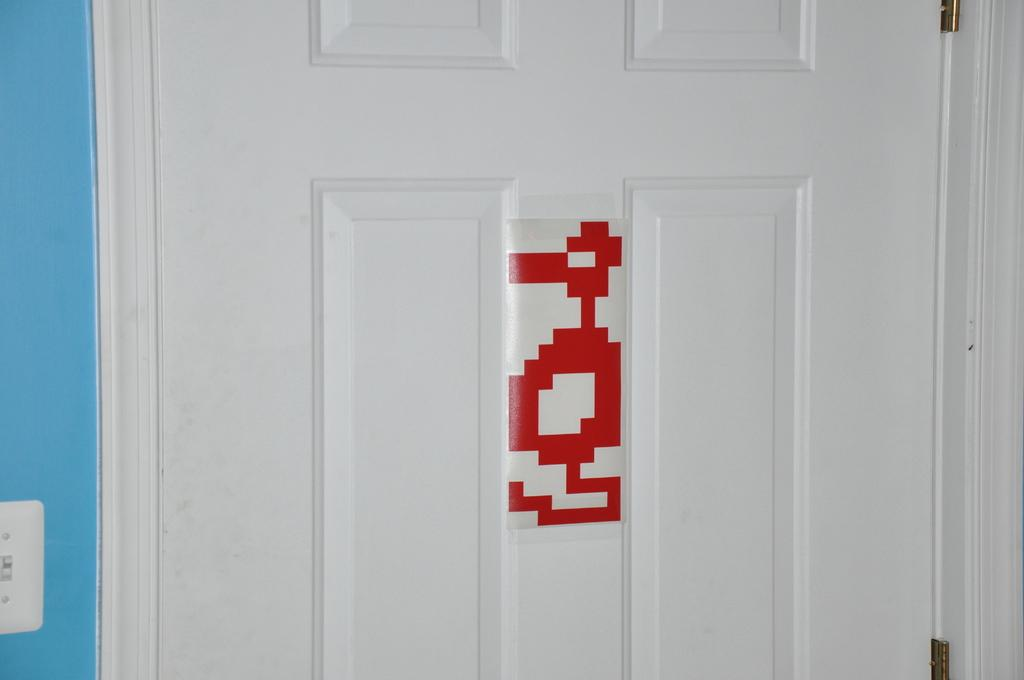What can be found in the image that serves as an entrance or exit? There is a door in the image. What is the color of the door? The door is white in color. Is there any decoration or pattern on the door? Yes, there is a design on the door. What color is the design on the door? The design is red in color. What else can be seen in the image besides the door? There is a wall in the image. What is the color of the wall? The wall is blue in color. Where is the paper store located in the image? There is no paper store present in the image. Can you tell me the name of the sister in the image? There is no sister present in the image. 